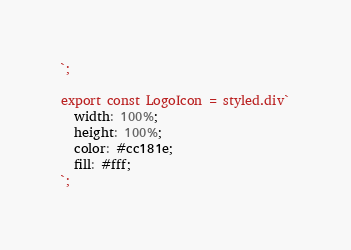<code> <loc_0><loc_0><loc_500><loc_500><_JavaScript_>`;

export const LogoIcon = styled.div`
  width: 100%;
  height: 100%;
  color: #cc181e;
  fill: #fff;
`;
</code> 